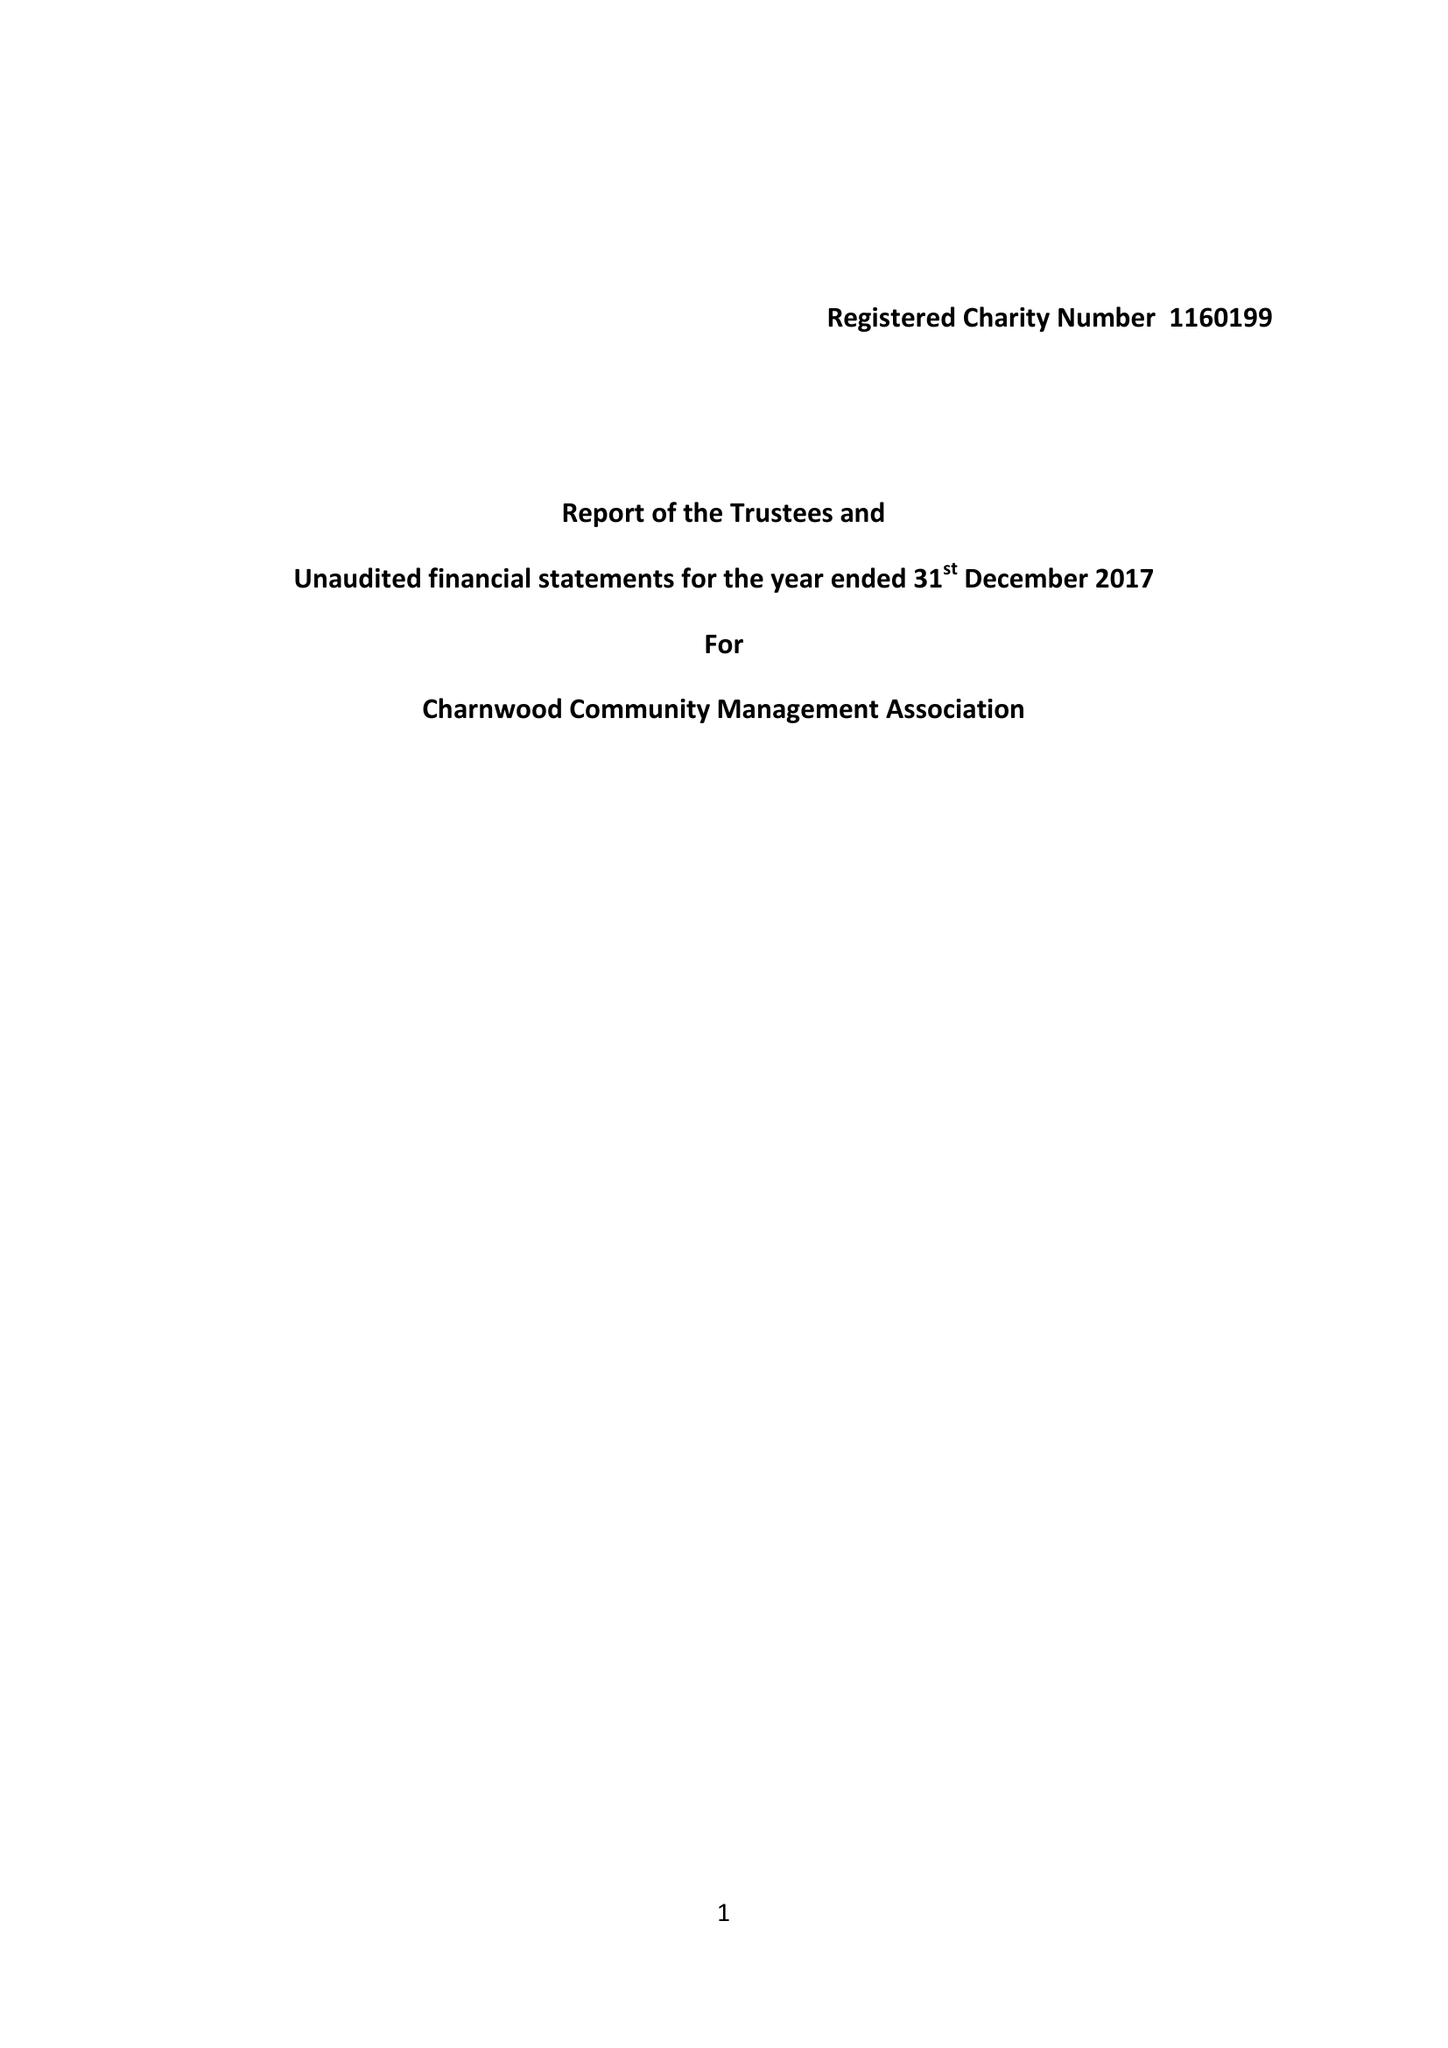What is the value for the address__postcode?
Answer the question using a single word or phrase. SG5 2HZ 